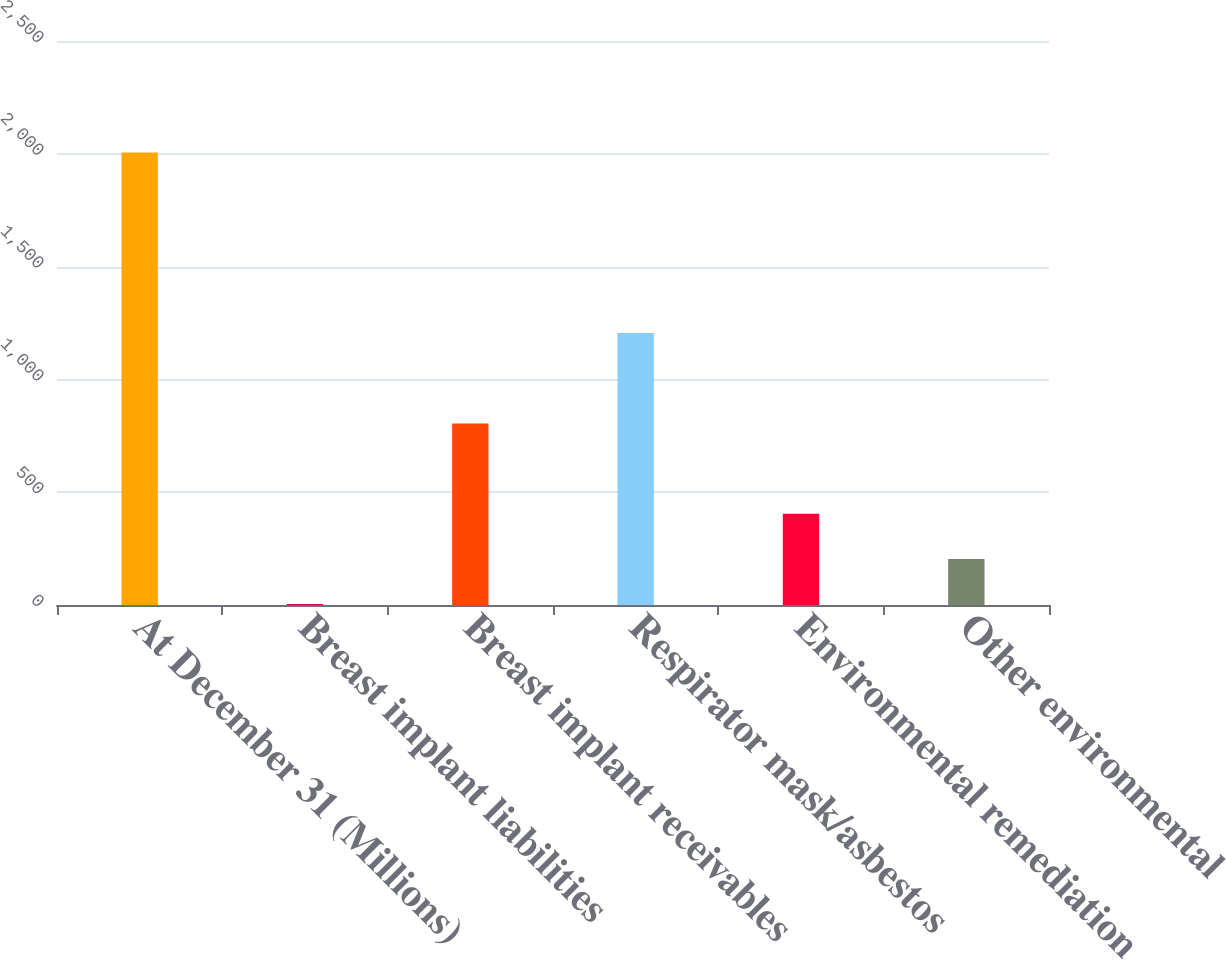Convert chart. <chart><loc_0><loc_0><loc_500><loc_500><bar_chart><fcel>At December 31 (Millions)<fcel>Breast implant liabilities<fcel>Breast implant receivables<fcel>Respirator mask/asbestos<fcel>Environmental remediation<fcel>Other environmental<nl><fcel>2006<fcel>4<fcel>804.8<fcel>1205.2<fcel>404.4<fcel>204.2<nl></chart> 